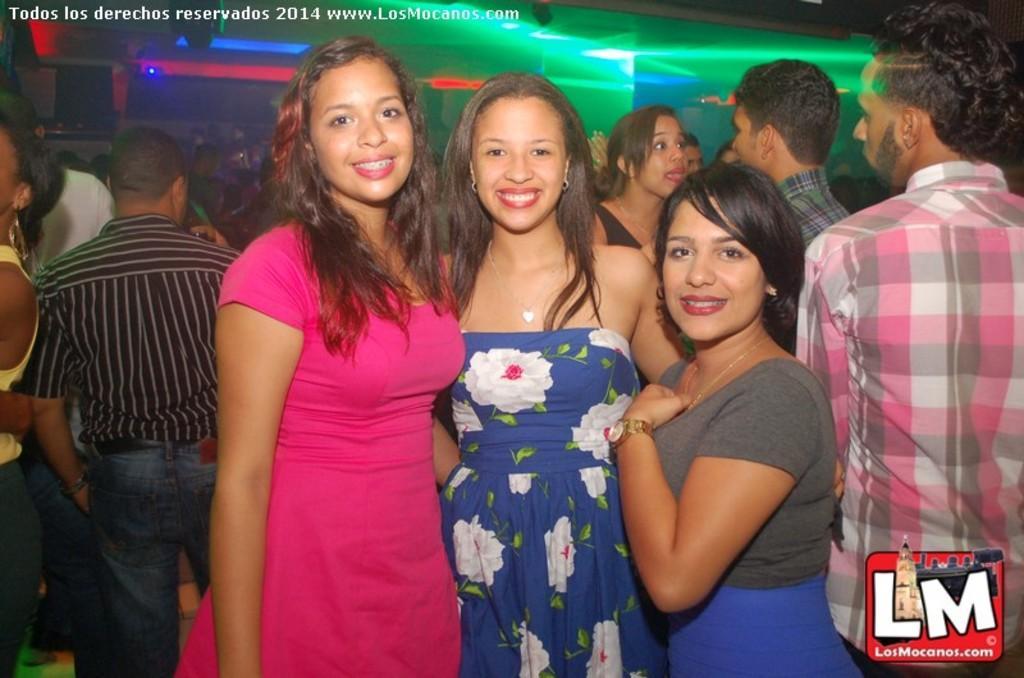Please provide a concise description of this image. In this image I can see number of people are standing. In the front I can see three women and on their faces I can see smile. On the top left side and on the the bottom right corner I can see watermarks. I can also see number of lights on the top of this image. 